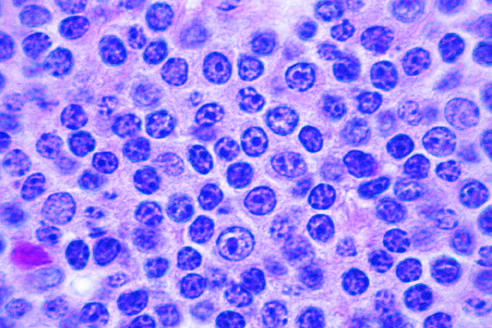s a prolymphocyte, a larger cell with a centrally placed nucleolus, present in this field?
Answer the question using a single word or phrase. Yes 